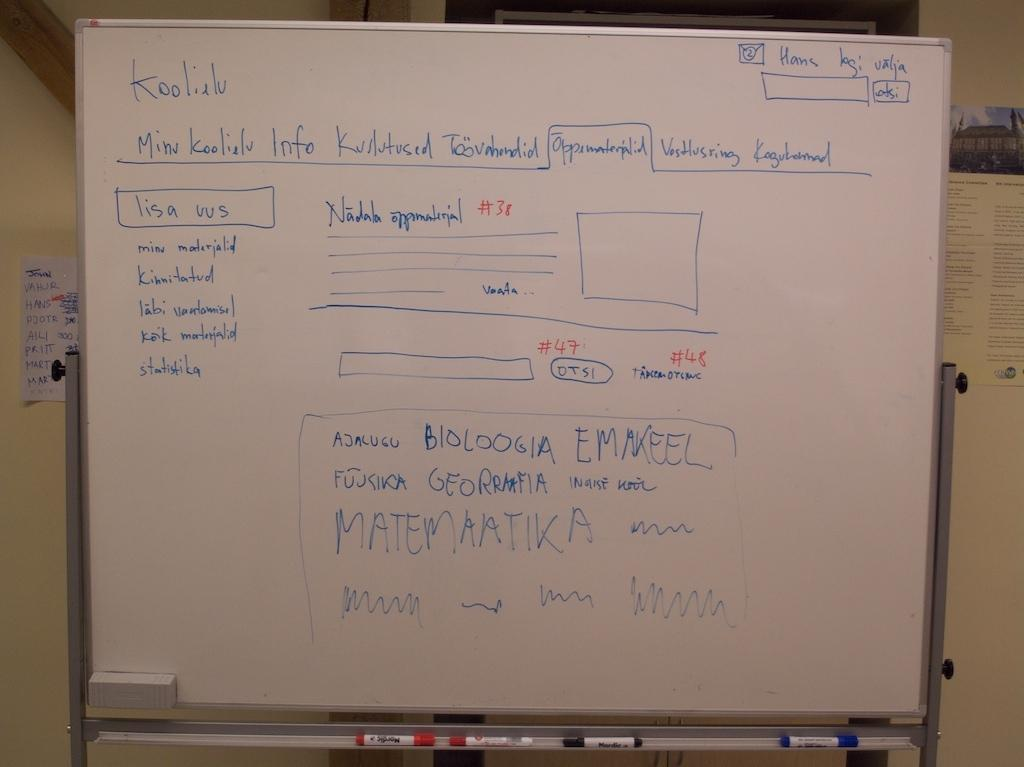<image>
Offer a succinct explanation of the picture presented. Information on a dry erase board lists several sections numbered in red, including #38, #47, and #48. 